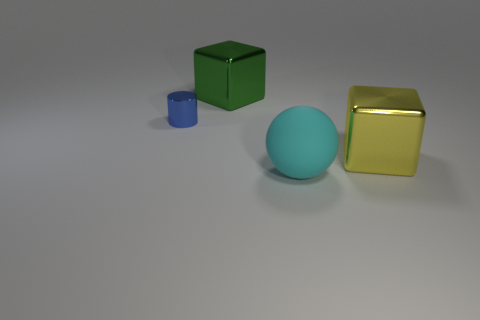There is a large thing behind the metal thing on the left side of the big block that is behind the tiny blue cylinder; what is its shape?
Your answer should be very brief. Cube. There is a cube that is right of the ball; does it have the same size as the blue metal object that is in front of the green thing?
Your response must be concise. No. How many other large things are the same material as the blue object?
Provide a succinct answer. 2. How many cylinders are behind the metallic block that is in front of the large metal block that is behind the blue metallic object?
Offer a very short reply. 1. Do the big yellow metal thing and the green metallic object have the same shape?
Keep it short and to the point. Yes. Are there any other metallic objects of the same shape as the green object?
Ensure brevity in your answer.  Yes. What is the shape of the yellow metallic thing that is the same size as the rubber sphere?
Provide a short and direct response. Cube. What material is the large cube that is in front of the metallic object on the left side of the block on the left side of the big cyan object?
Your answer should be very brief. Metal. Does the cyan matte object have the same size as the green block?
Make the answer very short. Yes. What is the big sphere made of?
Give a very brief answer. Rubber. 